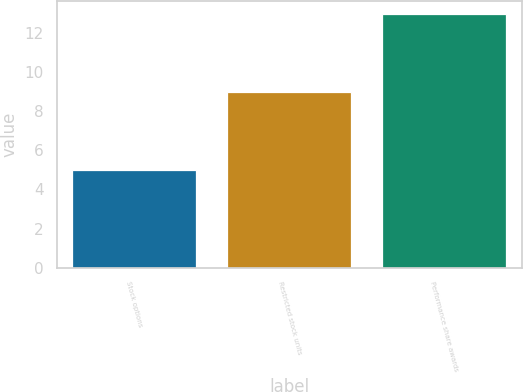Convert chart. <chart><loc_0><loc_0><loc_500><loc_500><bar_chart><fcel>Stock options<fcel>Restricted stock units<fcel>Performance share awards<nl><fcel>5<fcel>9<fcel>13<nl></chart> 